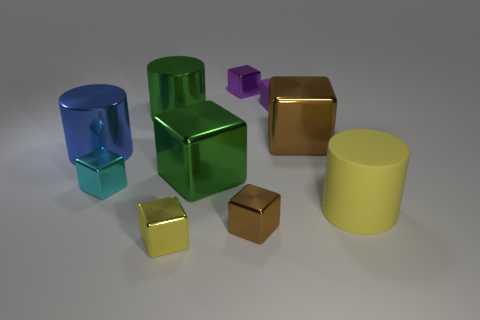Is the shape of the small cyan thing the same as the small brown shiny object in front of the large brown cube? Yes, the small cyan object has the same cube shape as the small brown object in front of the larger brown cube; both exhibit the characteristic six faces of a cube and are distinguishable from the other objects in the image which have various other shapes. 